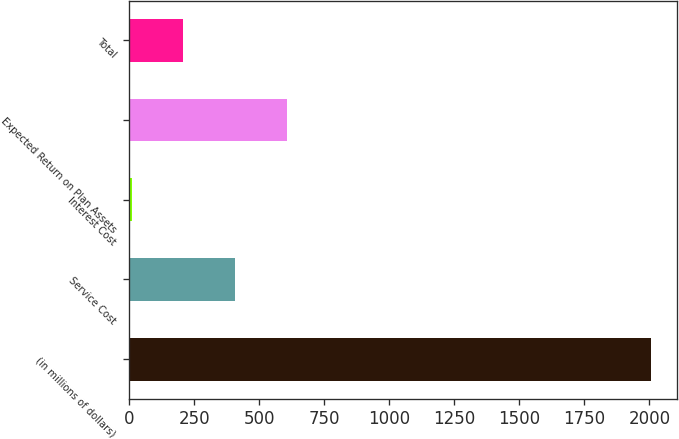Convert chart to OTSL. <chart><loc_0><loc_0><loc_500><loc_500><bar_chart><fcel>(in millions of dollars)<fcel>Service Cost<fcel>Interest Cost<fcel>Expected Return on Plan Assets<fcel>Total<nl><fcel>2006<fcel>407.6<fcel>8<fcel>607.4<fcel>207.8<nl></chart> 